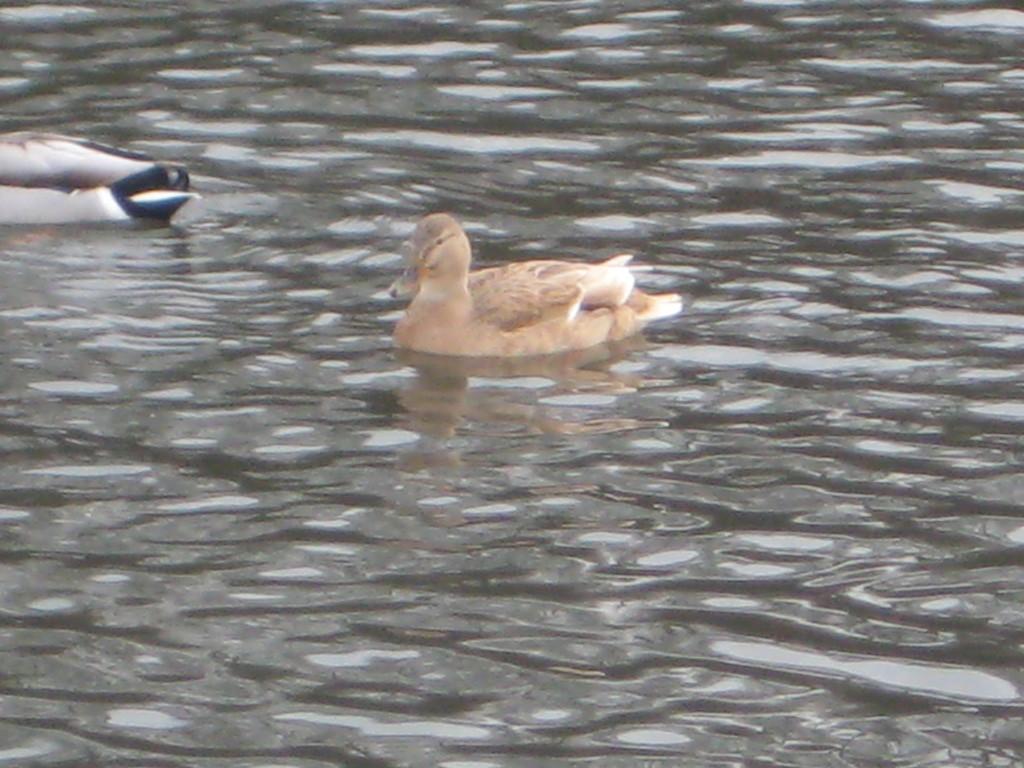Could you give a brief overview of what you see in this image? In this image, we can see birds are swimming in the water. 